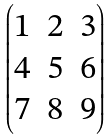<formula> <loc_0><loc_0><loc_500><loc_500>\begin{pmatrix} 1 & 2 & 3 \\ 4 & 5 & 6 \\ 7 & 8 & 9 \end{pmatrix}</formula> 